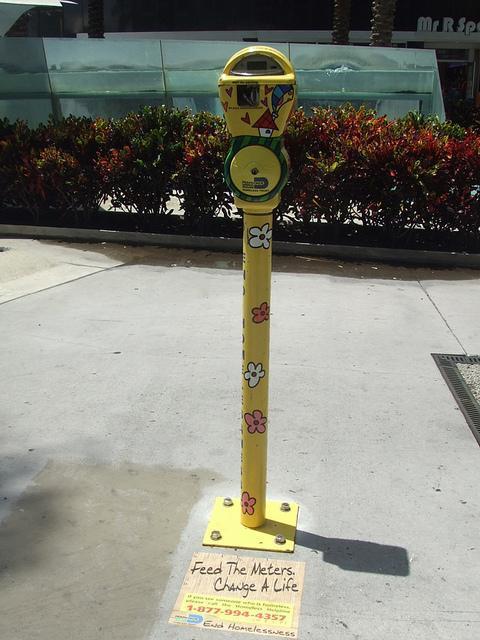How many potted plants are in the photo?
Give a very brief answer. 3. 